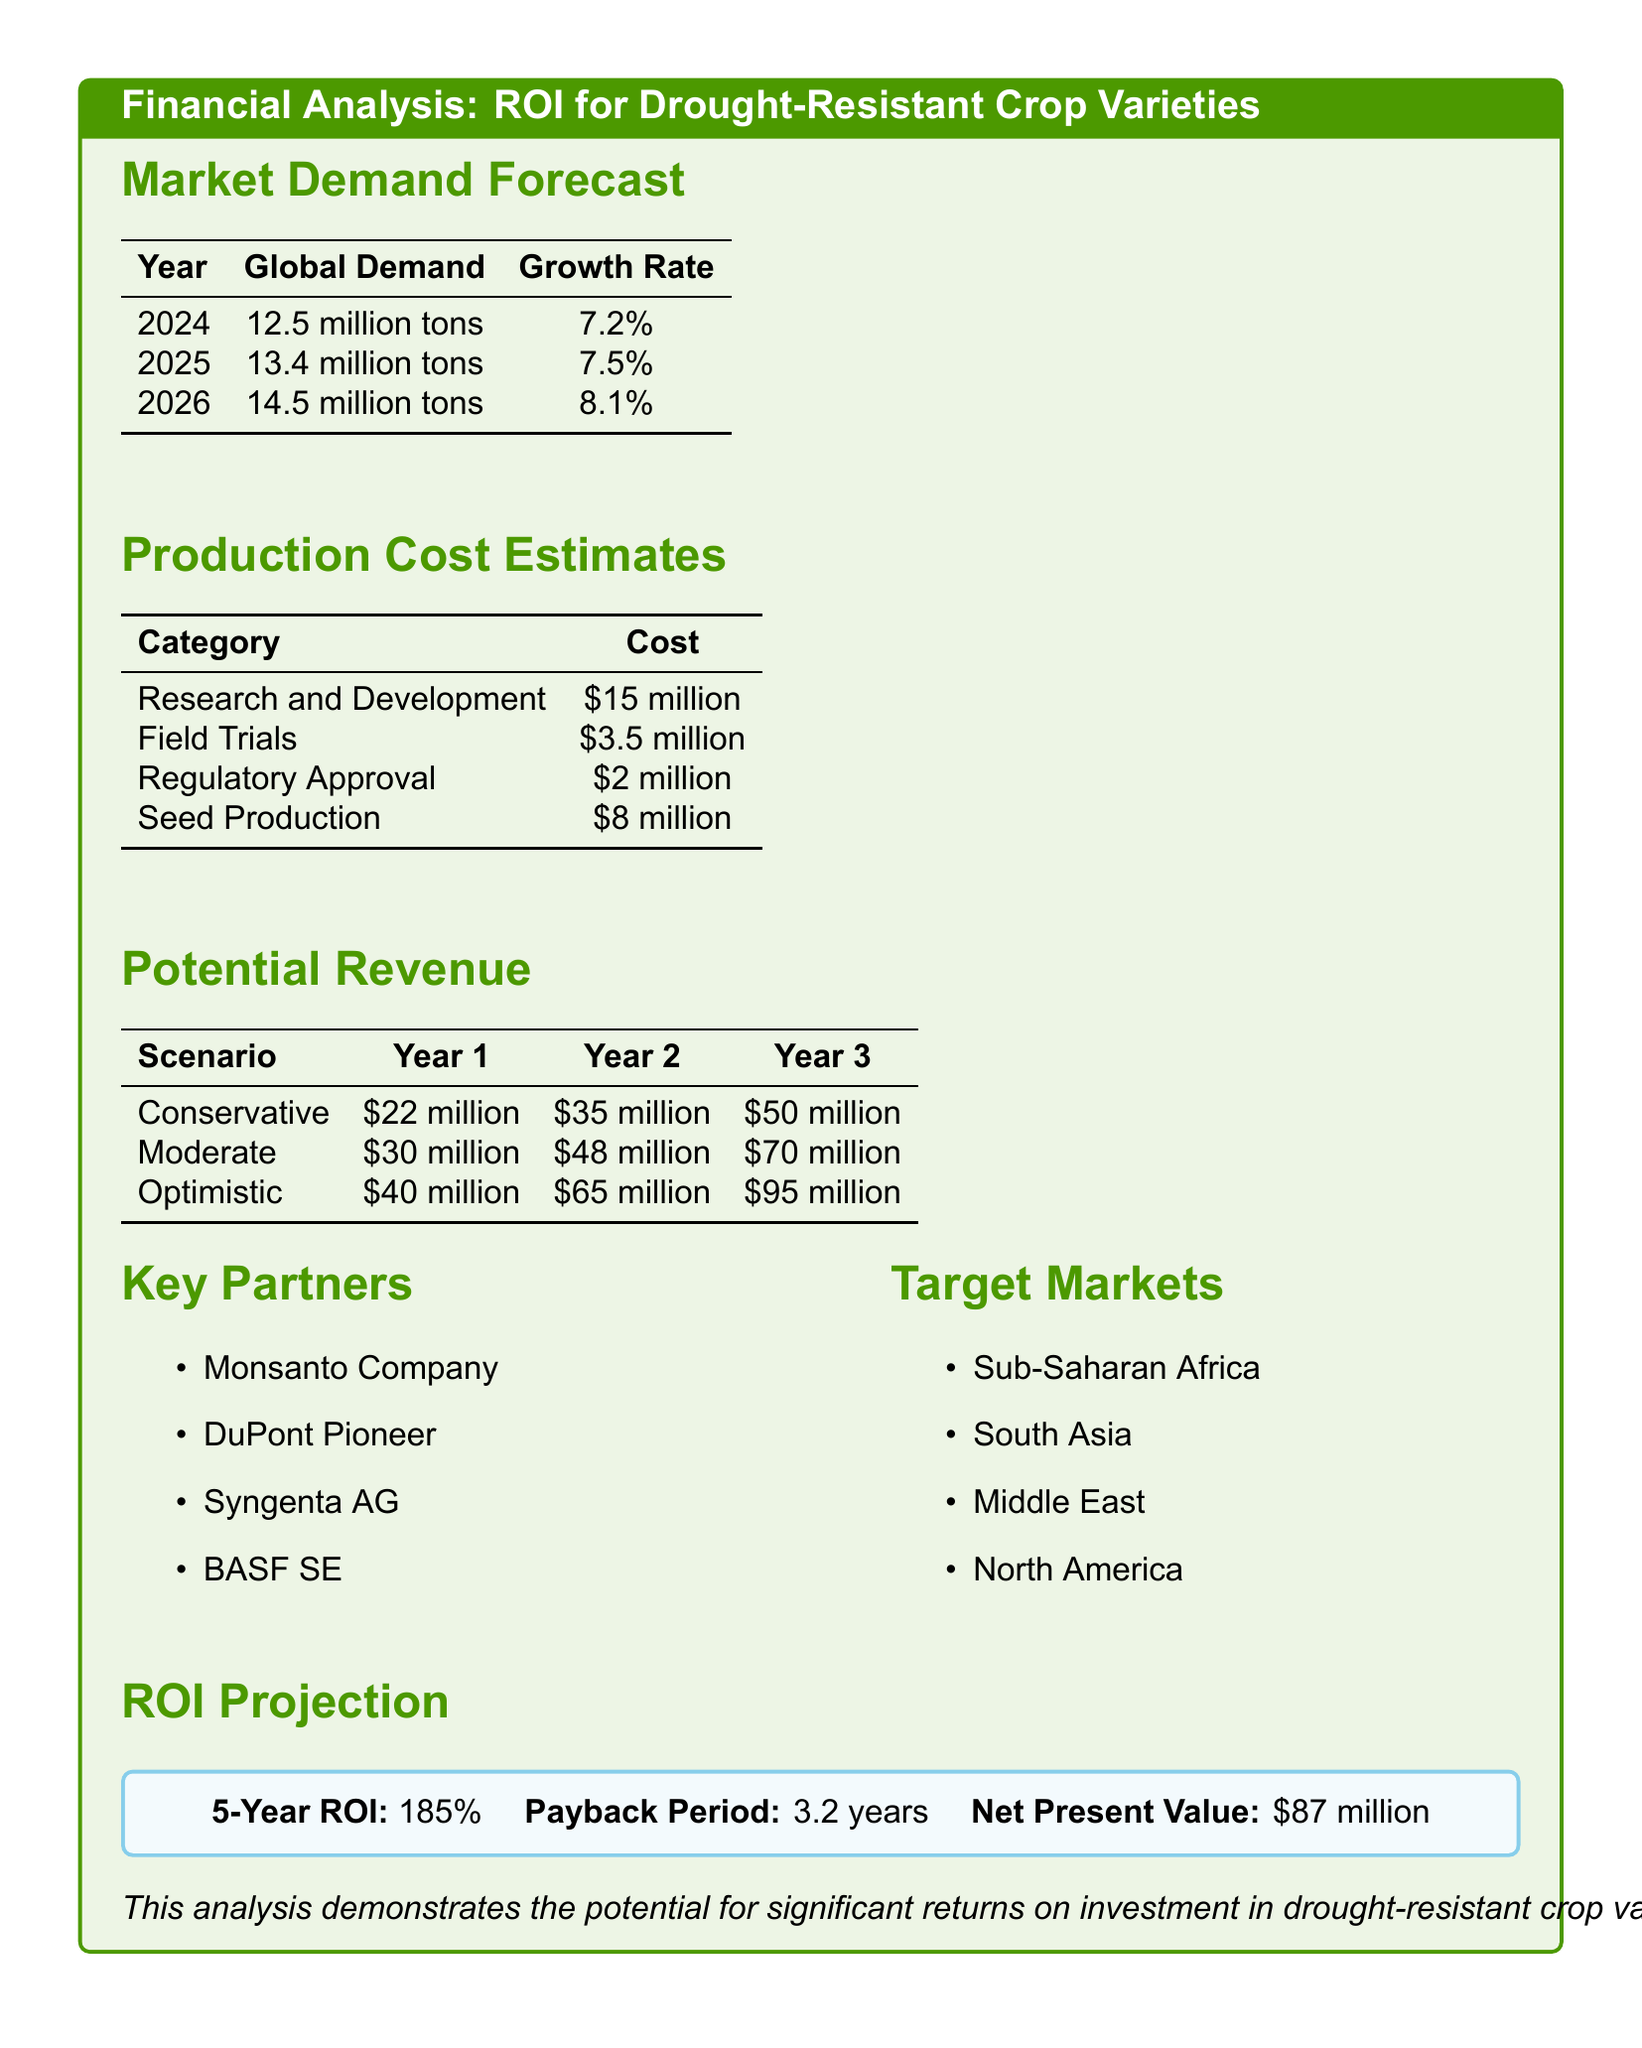What is the global demand for 2025? The document provides a table that states the global demand for 2025 is 13.4 million tons.
Answer: 13.4 million tons What is the growth rate for global demand in 2026? The document lists the growth rate for global demand in 2026 as 8.1%.
Answer: 8.1% What is the total estimated cost for Research and Development? The document specifies the cost for Research and Development as $15 million.
Answer: $15 million What is the payback period for the investment? The ROI projection section provides the payback period as 3.2 years.
Answer: 3.2 years Which scenario projects the highest revenue in year 3? The potential revenue section indicates that the optimistic scenario has the highest revenue in year 3, which is $95 million.
Answer: $95 million What is the total cost for Seed Production? The document indicates the cost for Seed Production is $8 million.
Answer: $8 million Which regions are identified as target markets? The document lists Sub-Saharan Africa, South Asia, Middle East, and North America as target markets.
Answer: Sub-Saharan Africa, South Asia, Middle East, North America What is the 5-year ROI percentage? The document states that the 5-year ROI is 185%.
Answer: 185% Who is one of the key partners mentioned in the document? The document lists key partners that include Monsanto Company.
Answer: Monsanto Company 